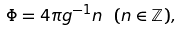Convert formula to latex. <formula><loc_0><loc_0><loc_500><loc_500>\Phi = 4 \pi g ^ { - 1 } n \ ( n \in \mathbb { Z } ) ,</formula> 